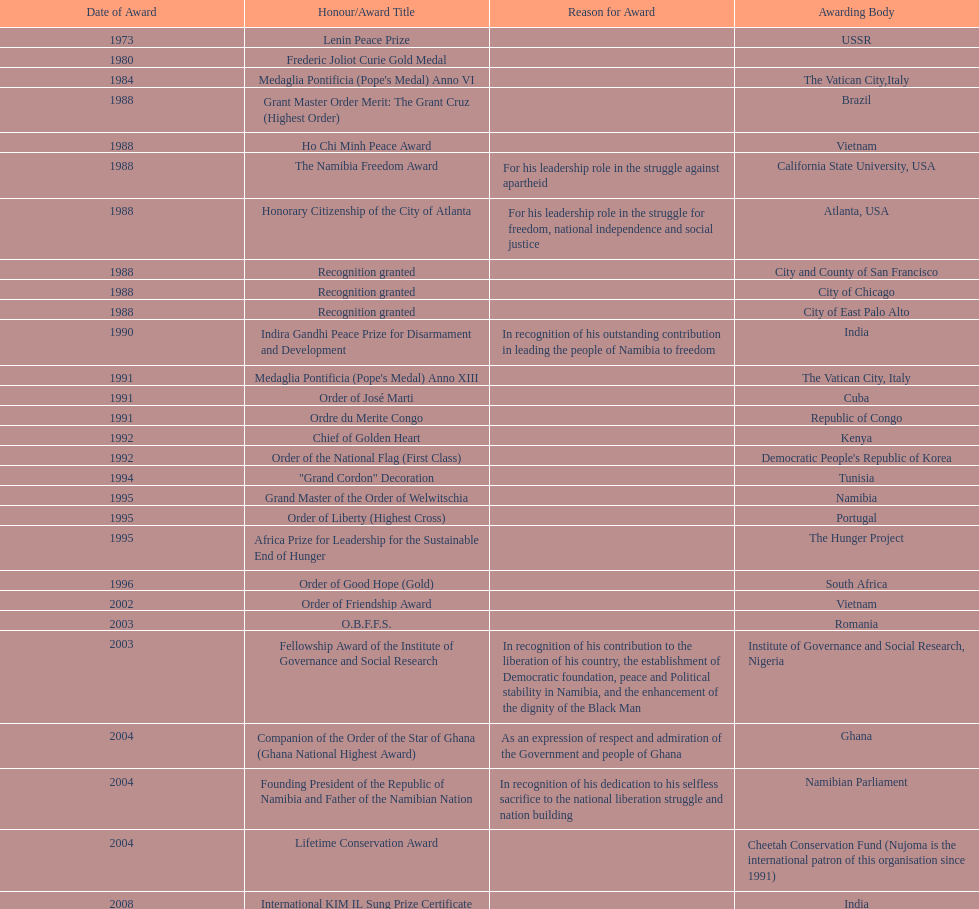What were the total number of honors/award titles listed according to this chart? 29. Could you parse the entire table as a dict? {'header': ['Date of Award', 'Honour/Award Title', 'Reason for Award', 'Awarding Body'], 'rows': [['1973', 'Lenin Peace Prize', '', 'USSR'], ['1980', 'Frederic Joliot Curie Gold Medal', '', ''], ['1984', "Medaglia Pontificia (Pope's Medal) Anno VI", '', 'The Vatican City,Italy'], ['1988', 'Grant Master Order Merit: The Grant Cruz (Highest Order)', '', 'Brazil'], ['1988', 'Ho Chi Minh Peace Award', '', 'Vietnam'], ['1988', 'The Namibia Freedom Award', 'For his leadership role in the struggle against apartheid', 'California State University, USA'], ['1988', 'Honorary Citizenship of the City of Atlanta', 'For his leadership role in the struggle for freedom, national independence and social justice', 'Atlanta, USA'], ['1988', 'Recognition granted', '', 'City and County of San Francisco'], ['1988', 'Recognition granted', '', 'City of Chicago'], ['1988', 'Recognition granted', '', 'City of East Palo Alto'], ['1990', 'Indira Gandhi Peace Prize for Disarmament and Development', 'In recognition of his outstanding contribution in leading the people of Namibia to freedom', 'India'], ['1991', "Medaglia Pontificia (Pope's Medal) Anno XIII", '', 'The Vatican City, Italy'], ['1991', 'Order of José Marti', '', 'Cuba'], ['1991', 'Ordre du Merite Congo', '', 'Republic of Congo'], ['1992', 'Chief of Golden Heart', '', 'Kenya'], ['1992', 'Order of the National Flag (First Class)', '', "Democratic People's Republic of Korea"], ['1994', '"Grand Cordon" Decoration', '', 'Tunisia'], ['1995', 'Grand Master of the Order of Welwitschia', '', 'Namibia'], ['1995', 'Order of Liberty (Highest Cross)', '', 'Portugal'], ['1995', 'Africa Prize for Leadership for the Sustainable End of Hunger', '', 'The Hunger Project'], ['1996', 'Order of Good Hope (Gold)', '', 'South Africa'], ['2002', 'Order of Friendship Award', '', 'Vietnam'], ['2003', 'O.B.F.F.S.', '', 'Romania'], ['2003', 'Fellowship Award of the Institute of Governance and Social Research', 'In recognition of his contribution to the liberation of his country, the establishment of Democratic foundation, peace and Political stability in Namibia, and the enhancement of the dignity of the Black Man', 'Institute of Governance and Social Research, Nigeria'], ['2004', 'Companion of the Order of the Star of Ghana (Ghana National Highest Award)', 'As an expression of respect and admiration of the Government and people of Ghana', 'Ghana'], ['2004', 'Founding President of the Republic of Namibia and Father of the Namibian Nation', 'In recognition of his dedication to his selfless sacrifice to the national liberation struggle and nation building', 'Namibian Parliament'], ['2004', 'Lifetime Conservation Award', '', 'Cheetah Conservation Fund (Nujoma is the international patron of this organisation since 1991)'], ['2008', 'International KIM IL Sung Prize Certificate', '', 'India'], ['2010', 'Sir Seretse Khama SADC Meda', '', 'SADC']]} 